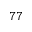<formula> <loc_0><loc_0><loc_500><loc_500>^ { 7 7 }</formula> 